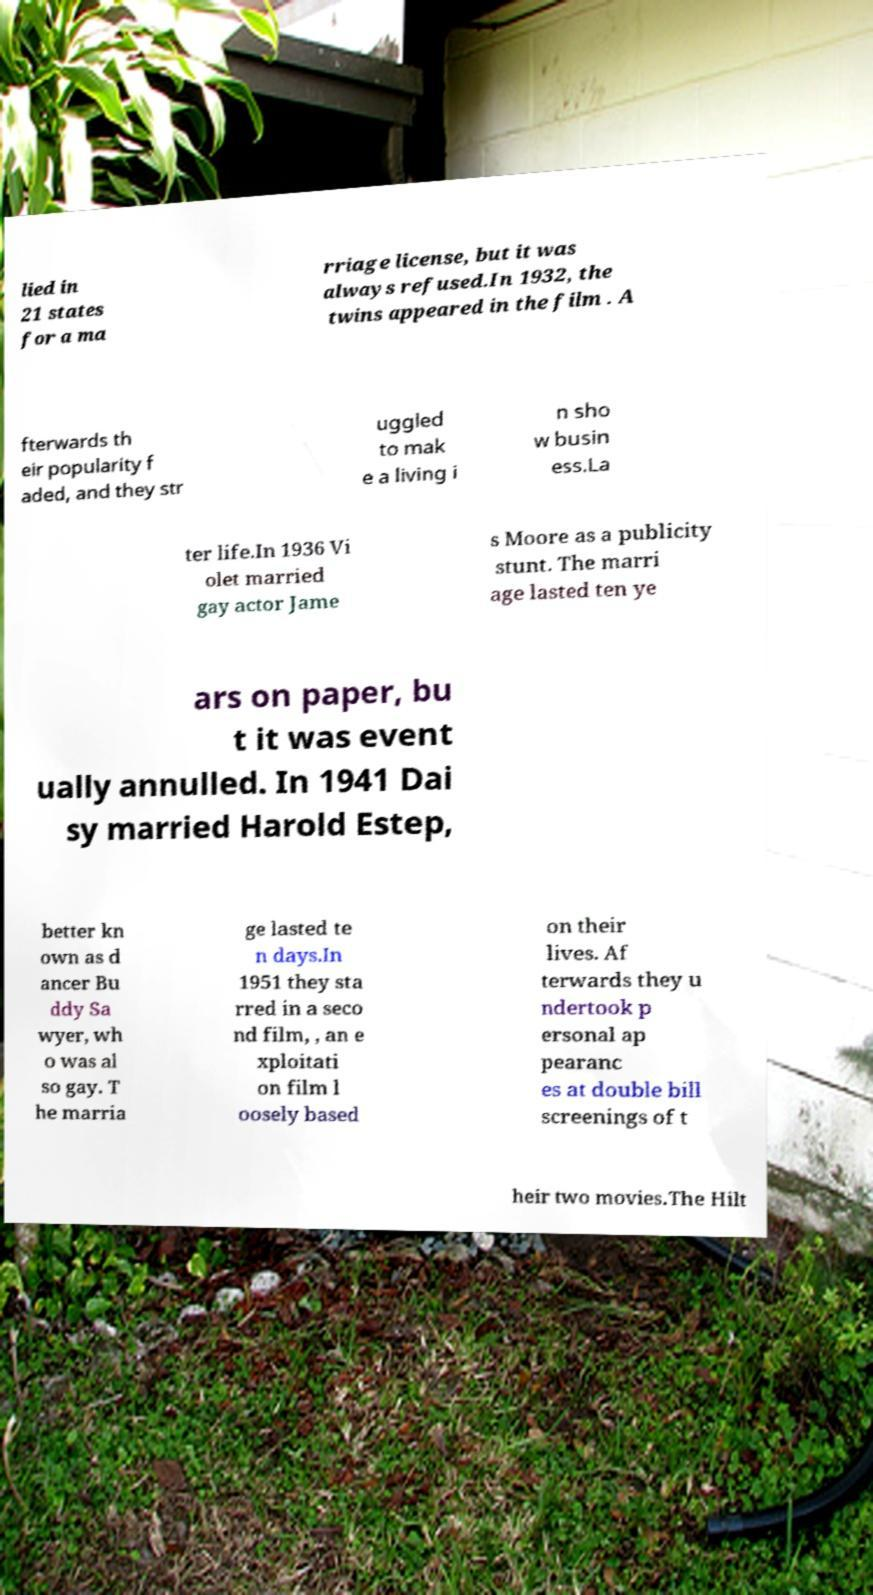Please read and relay the text visible in this image. What does it say? lied in 21 states for a ma rriage license, but it was always refused.In 1932, the twins appeared in the film . A fterwards th eir popularity f aded, and they str uggled to mak e a living i n sho w busin ess.La ter life.In 1936 Vi olet married gay actor Jame s Moore as a publicity stunt. The marri age lasted ten ye ars on paper, bu t it was event ually annulled. In 1941 Dai sy married Harold Estep, better kn own as d ancer Bu ddy Sa wyer, wh o was al so gay. T he marria ge lasted te n days.In 1951 they sta rred in a seco nd film, , an e xploitati on film l oosely based on their lives. Af terwards they u ndertook p ersonal ap pearanc es at double bill screenings of t heir two movies.The Hilt 